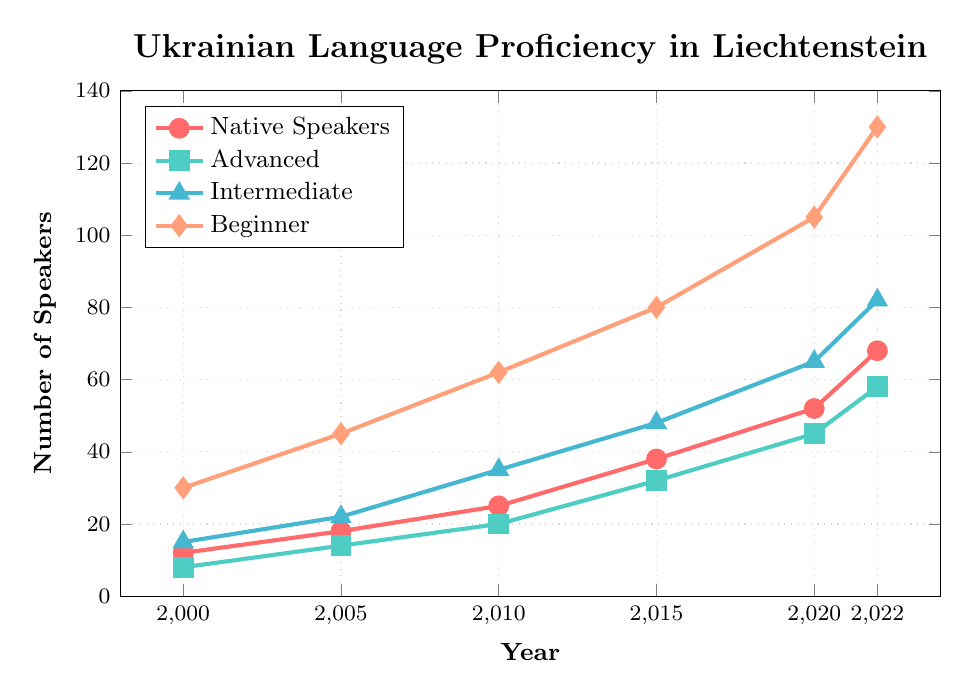Which year has the highest number of Beginner speakers? The tallest visual data point for the Beginner speakers is seen in 2022. The value is 130, indicating the highest number of Beginner speakers.
Answer: 2022 Which proficiency level showed the greatest increase in speakers between 2000 and 2022? Calculate the increase for each proficiency level: Native Speakers (68-12=56), Advanced (58-8=50), Intermediate (82-15=67), and Beginner (130-30=100). The Beginner level shows the greatest increase, with a rise of 100 speakers.
Answer: Beginner By how many people did the number of Advanced speakers increase from 2005 to 2020? In 2005, there were 14 Advanced speakers. In 2020, there were 45. The increase is 45 - 14 = 31 speakers.
Answer: 31 Which year showed the biggest jump in the number of Native Speakers compared to the previous period? Comparing the increases: 2000-2005 (18-12=6), 2005-2010 (25-18=7), 2010-2015 (38-25=13), 2015-2020 (52-38=14), 2020-2022 (68-52=16). The biggest jump is from 2020 to 2022 with an increase of 16 speakers.
Answer: 2020 to 2022 How many more Intermediate speakers were there in 2015 than in 2000? The number of Intermediate speakers in 2015 was 48 and in 2000 was 15. The difference is 48 - 15 = 33 speakers.
Answer: 33 In which year did the number of Advanced speakers surpass the number of Native speakers? By checking the graph, the year when the number of Advanced speakers first surpasses Native speakers is between 2000 and 2005. In 2005, Advanced speakers (14) surpassed Native speakers (18).
Answer: 2005 What is the total number of Ukrainian language speakers recorded in 2020? Add the number of speakers from all proficiency levels in 2020: 52 Native, 45 Advanced, 65 Intermediate, and 105 Beginner. Total: 52 + 45 + 65 + 105 = 267.
Answer: 267 Compare the growth trend of Intermediate and Advanced speakers. Which showed a steeper increase visually? Visually comparing the slopes of the lines, the Intermediate speakers' line appears steeper than the Advanced speakers' line from 2000 to 2022, indicating a steeper increase.
Answer: Intermediate What is the combined number of Beginner and Native speakers in 2022? The number of Beginner speakers in 2022 is 130 and Native speakers is 68. Their combined total is 130 + 68 = 198.
Answer: 198 